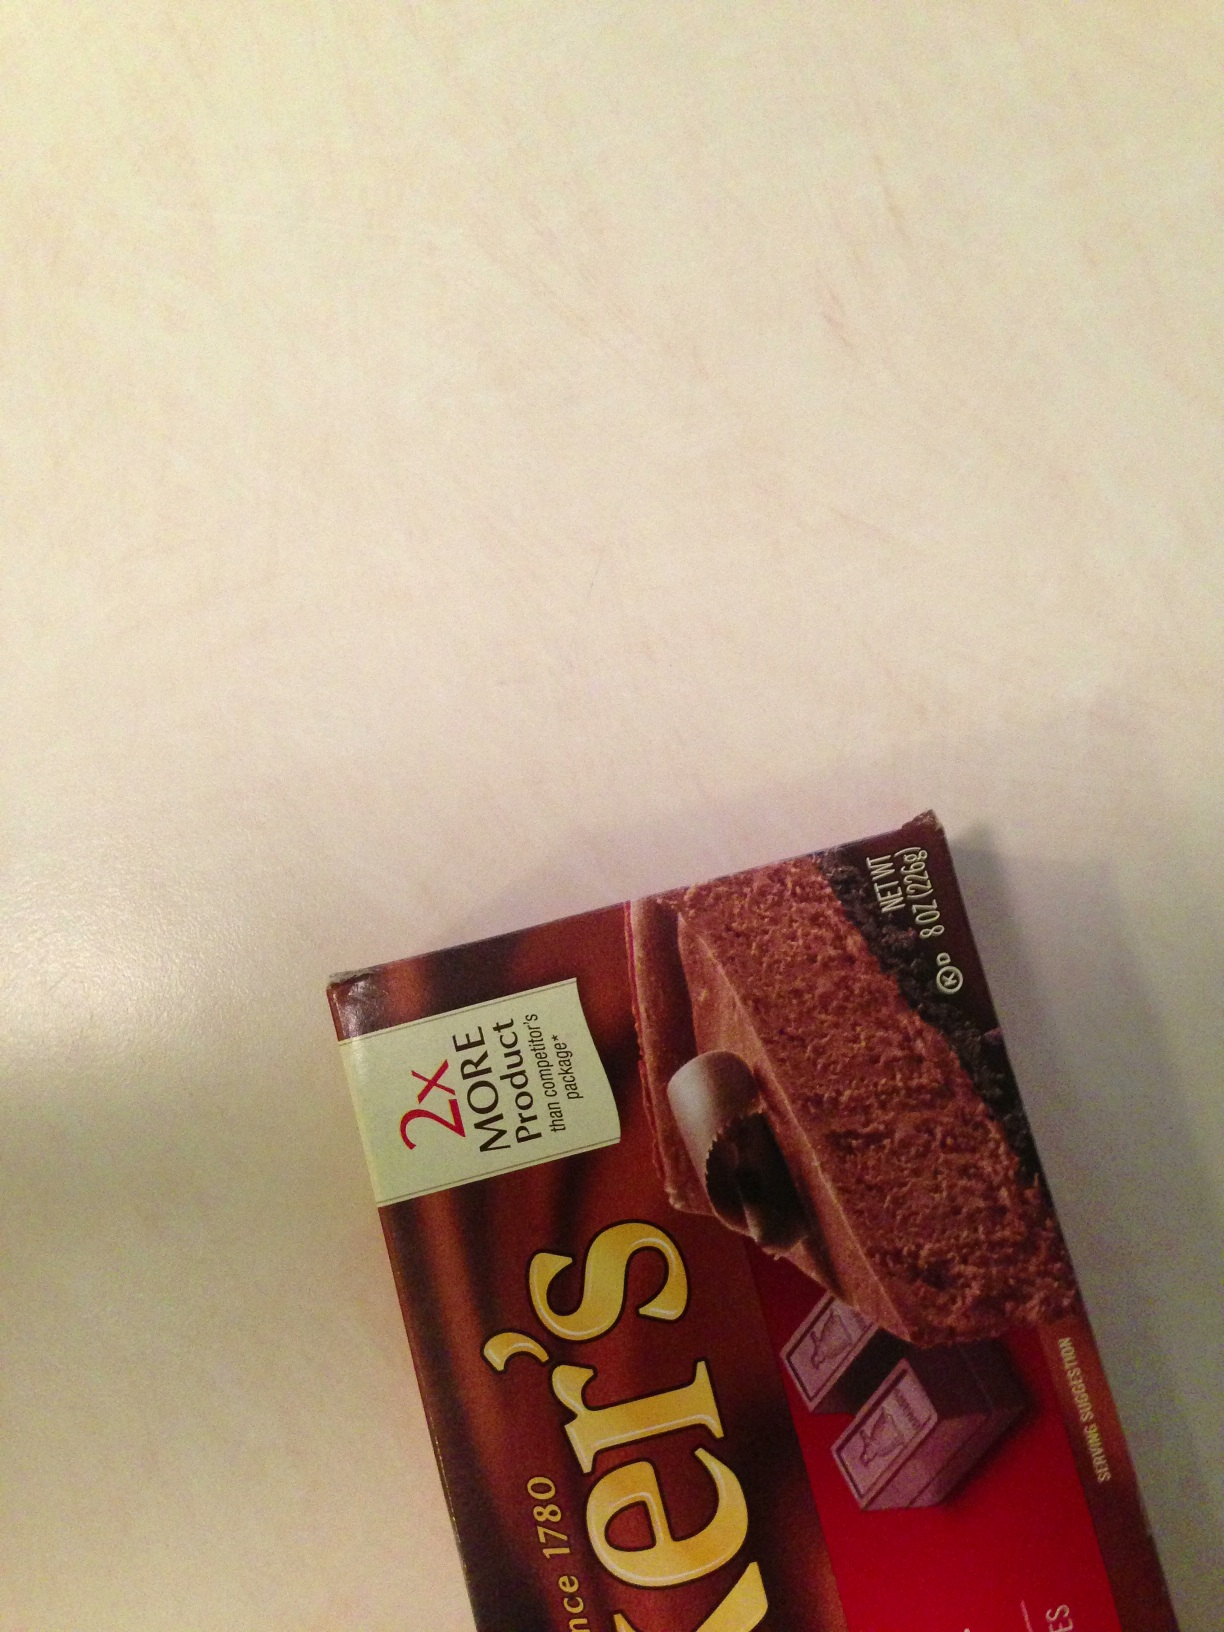What is the primary use of this chocolate? The primary use of Baker's unsweetened chocolate is for baking. It's often used in recipes for cakes, brownies, and other desserts where bakers prefer to control the amount of sweetness by adding their own sugar. Can you suggest a popular recipe using this chocolate? Absolutely! One of the most popular recipes using Baker's unsweetened chocolate is classic chocolate brownies. Here’s a quick recipe:

**Ingredients:**
- 4 squares (1 oz each) Baker’s unsweetened chocolate
- 3/4 cup (1 1/2 sticks) butter
- 2 cups sugar
- 3 eggs
- 1 tsp vanilla
- 1 cup all-purpose flour
- 1 cup chopped nuts (optional)

**Instructions:**
1. Preheat oven to 350°F.
2. Microwave chocolate and butter in large microwaveable bowl on high for 2 minutes or until butter is melted. Stir until chocolate is completely melted.
3. Stir sugar into the chocolate mixture until well blended. Mix in eggs and vanilla. Add flour and nuts, mix well.
4. Spread into greased 13x9 inch pan.
5. Bake for 30-35 minutes or until toothpick inserted into the center comes out with fudgy crumbs. Cool in pan; cut into squares and enjoy! Are there any nutritional benefits to using unsweetened chocolate? Yes, there are several nutritional benefits to using unsweetened chocolate. Unsweetened chocolate is a rich source of antioxidants, which can help fight off free radicals in the body. It's also a good source of iron, magnesium, and fiber. Additionally, since it contains no added sugar, it is lower in calories compared to sweetened chocolate, making it a healthier option for those looking to reduce sugar intake. Create a fictional scenario where this chocolate could be used in an unexpected way. Imagine a world where chocolate is not only a delicious treat but also a powerful energy source. In this world, a brilliant scientist discovers that the high concentration of antioxidants and natural compounds in Baker's unsweetened chocolate can be harnessed to create a new type of eco-friendly battery. These chocolate batteries are capable of storing and releasing energy at unprecedented efficiency. Soon, chocolate-powered cars, phones, and even spaceships become the norm. People start viewing unsweetened chocolate not just as a baking ingredient but as a revolutionary technology that powers their everyday lives. Who would have thought that a simple bar of unsweetened chocolate could reshape the future of energy? 
Write a short review of this product. Baker's Unsweetened Chocolate is a top-notch product for baking enthusiasts. Its rich, deep chocolate flavor is perfect for recipes where you want complete control over the sweetness. Whether you're making brownies, cakes, or chocolate sauces, this unsweetened chocolate provides a robust base that can be tailored to your taste. Additionally, its long-standing reputation and consistent quality make it a reliable choice for any kitchen. Highly recommended for serious bakers! 
Imagine this chocolate bar has a secret ingredient. What could it be and how would it affect the taste? Imagine if this chocolate bar contained a secret ingredient, such as a rare, exotic vanilla bean extract sourced from deep within the Amazon rainforest. This vanilla bean has a unique flavor profile, adding a hint of floral and fruity notes to the intense chocolate taste. This secret ingredient would elevate the overall flavor, providing a complex and aromatic experience that lingers on the palate. Bakers and chefs would discover that when used in desserts, this special chocolate imparts a depth of flavor that intrigues and delights anyone lucky enough to try it. 